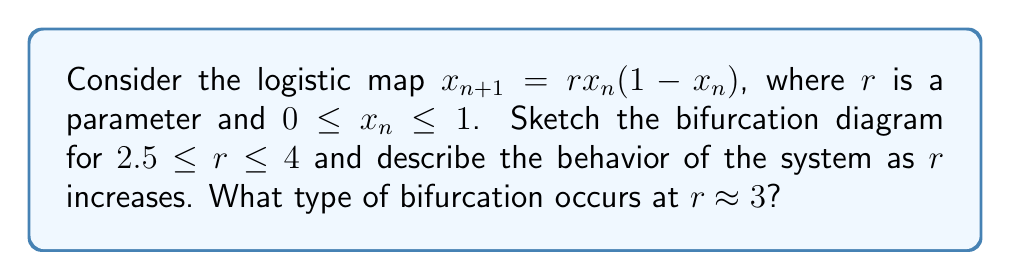Solve this math problem. To analyze the bifurcation diagram of the logistic map:

1. Understand the logistic map equation:
   $x_{n+1} = rx_n(1-x_n)$, where $r$ is the parameter we'll vary.

2. For each value of $r$ in the range $2.5 \leq r \leq 4$:
   a) Iterate the map for a large number of times (e.g., 1000 iterations)
   b) Plot the last few hundred points (e.g., 200) on the diagram

3. As $r$ increases from 2.5 to 4, observe the behavior:

   - For $2.5 \leq r < 3$: The system converges to a single fixed point.
   
   - At $r \approx 3$: The fixed point becomes unstable, and the system bifurcates into two points. This is a period-doubling bifurcation.
   
   - As $r$ increases further: More period-doubling bifurcations occur, leading to 4, 8, 16, etc. points.
   
   - Around $r \approx 3.57$: The system enters chaos, with occasional "windows" of periodic behavior.

4. The bifurcation at $r \approx 3$ is called a period-doubling bifurcation because the system transitions from a single fixed point to an oscillation between two points.

[asy]
size(300,200);
import graph;

real f(real x, real r) {
  return r*x*(1-x);
}

for(real r=2.5; r<=4; r+=0.005) {
  real x = 0.5;
  for(int i=0; i<1000; ++i) {
    x = f(x,r);
    if(i > 800) {
      dot((r,x), black+0.2);
    }
  }
}

xaxis("r", xmin=2.5, xmax=4, arrow=Arrow);
yaxis("x", ymin=0, ymax=1, arrow=Arrow);

label("Period-doubling bifurcation", (3,0.7), E);
[/asy]
Answer: Period-doubling bifurcation at $r \approx 3$ 